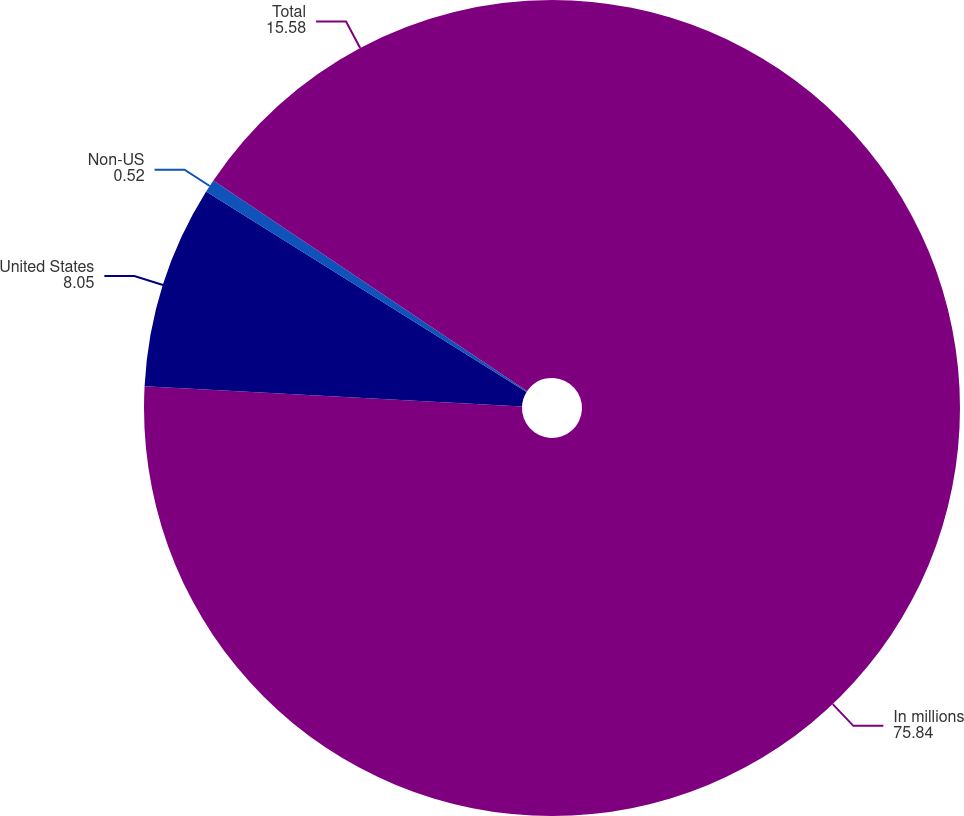Convert chart to OTSL. <chart><loc_0><loc_0><loc_500><loc_500><pie_chart><fcel>In millions<fcel>United States<fcel>Non-US<fcel>Total<nl><fcel>75.84%<fcel>8.05%<fcel>0.52%<fcel>15.58%<nl></chart> 